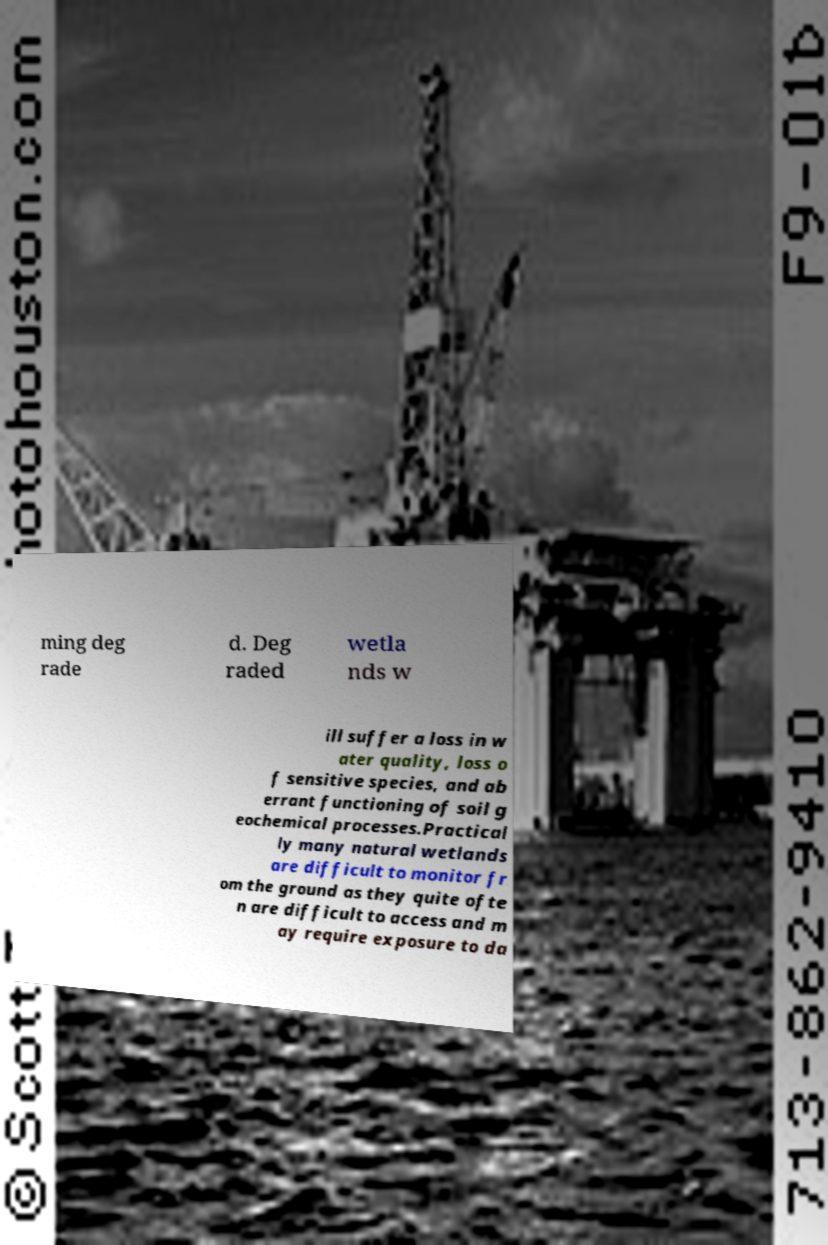What messages or text are displayed in this image? I need them in a readable, typed format. ming deg rade d. Deg raded wetla nds w ill suffer a loss in w ater quality, loss o f sensitive species, and ab errant functioning of soil g eochemical processes.Practical ly many natural wetlands are difficult to monitor fr om the ground as they quite ofte n are difficult to access and m ay require exposure to da 